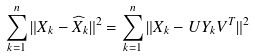<formula> <loc_0><loc_0><loc_500><loc_500>\sum _ { k = 1 } ^ { n } \| X _ { k } - \widehat { X } _ { k } \| ^ { 2 } = \sum _ { k = 1 } ^ { n } \| X _ { k } - U Y _ { k } V ^ { T } \| ^ { 2 }</formula> 